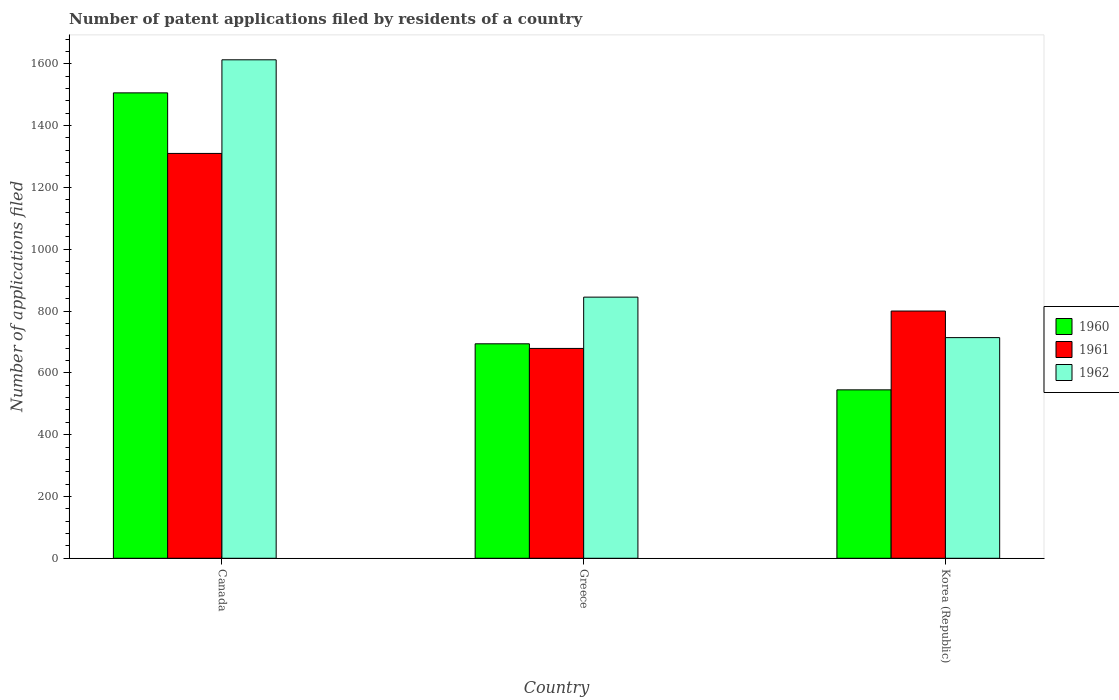How many groups of bars are there?
Give a very brief answer. 3. Are the number of bars on each tick of the X-axis equal?
Provide a short and direct response. Yes. What is the number of applications filed in 1962 in Canada?
Offer a terse response. 1613. Across all countries, what is the maximum number of applications filed in 1961?
Provide a succinct answer. 1310. Across all countries, what is the minimum number of applications filed in 1960?
Give a very brief answer. 545. In which country was the number of applications filed in 1961 maximum?
Provide a succinct answer. Canada. In which country was the number of applications filed in 1962 minimum?
Ensure brevity in your answer.  Korea (Republic). What is the total number of applications filed in 1962 in the graph?
Provide a succinct answer. 3172. What is the difference between the number of applications filed in 1960 in Canada and that in Greece?
Provide a succinct answer. 812. What is the difference between the number of applications filed in 1961 in Greece and the number of applications filed in 1962 in Canada?
Provide a succinct answer. -934. What is the average number of applications filed in 1962 per country?
Offer a terse response. 1057.33. What is the difference between the number of applications filed of/in 1960 and number of applications filed of/in 1962 in Korea (Republic)?
Make the answer very short. -169. What is the ratio of the number of applications filed in 1960 in Greece to that in Korea (Republic)?
Provide a succinct answer. 1.27. What is the difference between the highest and the second highest number of applications filed in 1961?
Offer a very short reply. -510. What is the difference between the highest and the lowest number of applications filed in 1962?
Keep it short and to the point. 899. In how many countries, is the number of applications filed in 1962 greater than the average number of applications filed in 1962 taken over all countries?
Provide a succinct answer. 1. What does the 3rd bar from the left in Greece represents?
Ensure brevity in your answer.  1962. What does the 3rd bar from the right in Korea (Republic) represents?
Ensure brevity in your answer.  1960. How many bars are there?
Provide a short and direct response. 9. Are all the bars in the graph horizontal?
Your response must be concise. No. How many countries are there in the graph?
Ensure brevity in your answer.  3. Are the values on the major ticks of Y-axis written in scientific E-notation?
Ensure brevity in your answer.  No. Does the graph contain any zero values?
Keep it short and to the point. No. How many legend labels are there?
Offer a very short reply. 3. How are the legend labels stacked?
Provide a succinct answer. Vertical. What is the title of the graph?
Provide a succinct answer. Number of patent applications filed by residents of a country. Does "2005" appear as one of the legend labels in the graph?
Make the answer very short. No. What is the label or title of the X-axis?
Ensure brevity in your answer.  Country. What is the label or title of the Y-axis?
Keep it short and to the point. Number of applications filed. What is the Number of applications filed of 1960 in Canada?
Ensure brevity in your answer.  1506. What is the Number of applications filed of 1961 in Canada?
Make the answer very short. 1310. What is the Number of applications filed in 1962 in Canada?
Offer a terse response. 1613. What is the Number of applications filed in 1960 in Greece?
Offer a very short reply. 694. What is the Number of applications filed in 1961 in Greece?
Give a very brief answer. 679. What is the Number of applications filed of 1962 in Greece?
Make the answer very short. 845. What is the Number of applications filed of 1960 in Korea (Republic)?
Ensure brevity in your answer.  545. What is the Number of applications filed in 1961 in Korea (Republic)?
Your response must be concise. 800. What is the Number of applications filed in 1962 in Korea (Republic)?
Offer a very short reply. 714. Across all countries, what is the maximum Number of applications filed of 1960?
Provide a succinct answer. 1506. Across all countries, what is the maximum Number of applications filed of 1961?
Offer a very short reply. 1310. Across all countries, what is the maximum Number of applications filed in 1962?
Your answer should be compact. 1613. Across all countries, what is the minimum Number of applications filed of 1960?
Your answer should be very brief. 545. Across all countries, what is the minimum Number of applications filed in 1961?
Offer a very short reply. 679. Across all countries, what is the minimum Number of applications filed in 1962?
Make the answer very short. 714. What is the total Number of applications filed of 1960 in the graph?
Your response must be concise. 2745. What is the total Number of applications filed of 1961 in the graph?
Keep it short and to the point. 2789. What is the total Number of applications filed of 1962 in the graph?
Your answer should be very brief. 3172. What is the difference between the Number of applications filed of 1960 in Canada and that in Greece?
Your response must be concise. 812. What is the difference between the Number of applications filed of 1961 in Canada and that in Greece?
Offer a very short reply. 631. What is the difference between the Number of applications filed in 1962 in Canada and that in Greece?
Keep it short and to the point. 768. What is the difference between the Number of applications filed in 1960 in Canada and that in Korea (Republic)?
Offer a terse response. 961. What is the difference between the Number of applications filed in 1961 in Canada and that in Korea (Republic)?
Offer a very short reply. 510. What is the difference between the Number of applications filed of 1962 in Canada and that in Korea (Republic)?
Provide a short and direct response. 899. What is the difference between the Number of applications filed in 1960 in Greece and that in Korea (Republic)?
Give a very brief answer. 149. What is the difference between the Number of applications filed of 1961 in Greece and that in Korea (Republic)?
Your response must be concise. -121. What is the difference between the Number of applications filed in 1962 in Greece and that in Korea (Republic)?
Your response must be concise. 131. What is the difference between the Number of applications filed of 1960 in Canada and the Number of applications filed of 1961 in Greece?
Your answer should be very brief. 827. What is the difference between the Number of applications filed in 1960 in Canada and the Number of applications filed in 1962 in Greece?
Give a very brief answer. 661. What is the difference between the Number of applications filed in 1961 in Canada and the Number of applications filed in 1962 in Greece?
Your response must be concise. 465. What is the difference between the Number of applications filed in 1960 in Canada and the Number of applications filed in 1961 in Korea (Republic)?
Ensure brevity in your answer.  706. What is the difference between the Number of applications filed in 1960 in Canada and the Number of applications filed in 1962 in Korea (Republic)?
Provide a succinct answer. 792. What is the difference between the Number of applications filed of 1961 in Canada and the Number of applications filed of 1962 in Korea (Republic)?
Your answer should be compact. 596. What is the difference between the Number of applications filed in 1960 in Greece and the Number of applications filed in 1961 in Korea (Republic)?
Provide a short and direct response. -106. What is the difference between the Number of applications filed of 1961 in Greece and the Number of applications filed of 1962 in Korea (Republic)?
Give a very brief answer. -35. What is the average Number of applications filed in 1960 per country?
Your answer should be compact. 915. What is the average Number of applications filed of 1961 per country?
Your response must be concise. 929.67. What is the average Number of applications filed of 1962 per country?
Ensure brevity in your answer.  1057.33. What is the difference between the Number of applications filed in 1960 and Number of applications filed in 1961 in Canada?
Provide a short and direct response. 196. What is the difference between the Number of applications filed of 1960 and Number of applications filed of 1962 in Canada?
Ensure brevity in your answer.  -107. What is the difference between the Number of applications filed in 1961 and Number of applications filed in 1962 in Canada?
Give a very brief answer. -303. What is the difference between the Number of applications filed of 1960 and Number of applications filed of 1962 in Greece?
Offer a very short reply. -151. What is the difference between the Number of applications filed in 1961 and Number of applications filed in 1962 in Greece?
Ensure brevity in your answer.  -166. What is the difference between the Number of applications filed in 1960 and Number of applications filed in 1961 in Korea (Republic)?
Your response must be concise. -255. What is the difference between the Number of applications filed in 1960 and Number of applications filed in 1962 in Korea (Republic)?
Keep it short and to the point. -169. What is the difference between the Number of applications filed in 1961 and Number of applications filed in 1962 in Korea (Republic)?
Make the answer very short. 86. What is the ratio of the Number of applications filed of 1960 in Canada to that in Greece?
Provide a succinct answer. 2.17. What is the ratio of the Number of applications filed of 1961 in Canada to that in Greece?
Make the answer very short. 1.93. What is the ratio of the Number of applications filed in 1962 in Canada to that in Greece?
Make the answer very short. 1.91. What is the ratio of the Number of applications filed of 1960 in Canada to that in Korea (Republic)?
Make the answer very short. 2.76. What is the ratio of the Number of applications filed in 1961 in Canada to that in Korea (Republic)?
Give a very brief answer. 1.64. What is the ratio of the Number of applications filed of 1962 in Canada to that in Korea (Republic)?
Your answer should be compact. 2.26. What is the ratio of the Number of applications filed in 1960 in Greece to that in Korea (Republic)?
Your answer should be compact. 1.27. What is the ratio of the Number of applications filed of 1961 in Greece to that in Korea (Republic)?
Give a very brief answer. 0.85. What is the ratio of the Number of applications filed in 1962 in Greece to that in Korea (Republic)?
Provide a succinct answer. 1.18. What is the difference between the highest and the second highest Number of applications filed in 1960?
Ensure brevity in your answer.  812. What is the difference between the highest and the second highest Number of applications filed in 1961?
Provide a short and direct response. 510. What is the difference between the highest and the second highest Number of applications filed of 1962?
Your answer should be compact. 768. What is the difference between the highest and the lowest Number of applications filed in 1960?
Make the answer very short. 961. What is the difference between the highest and the lowest Number of applications filed of 1961?
Ensure brevity in your answer.  631. What is the difference between the highest and the lowest Number of applications filed of 1962?
Your response must be concise. 899. 